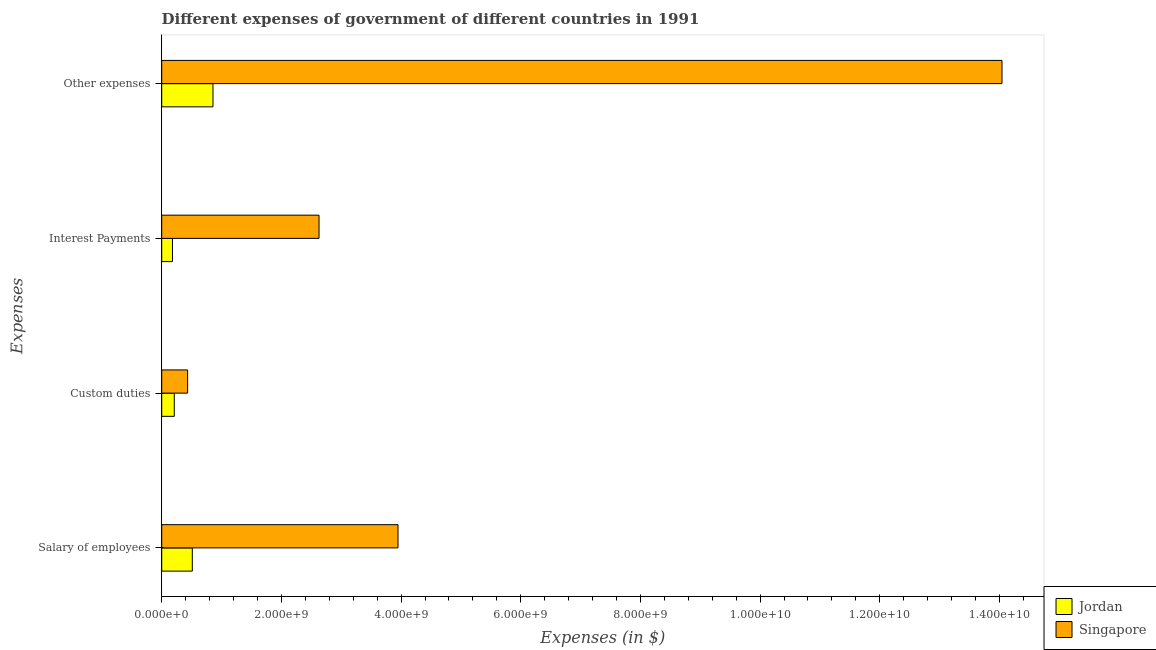How many different coloured bars are there?
Give a very brief answer. 2. Are the number of bars per tick equal to the number of legend labels?
Give a very brief answer. Yes. What is the label of the 4th group of bars from the top?
Make the answer very short. Salary of employees. What is the amount spent on interest payments in Jordan?
Provide a short and direct response. 1.80e+08. Across all countries, what is the maximum amount spent on custom duties?
Your answer should be very brief. 4.33e+08. Across all countries, what is the minimum amount spent on interest payments?
Provide a succinct answer. 1.80e+08. In which country was the amount spent on other expenses maximum?
Your response must be concise. Singapore. In which country was the amount spent on interest payments minimum?
Provide a succinct answer. Jordan. What is the total amount spent on custom duties in the graph?
Ensure brevity in your answer.  6.43e+08. What is the difference between the amount spent on other expenses in Singapore and that in Jordan?
Give a very brief answer. 1.32e+1. What is the difference between the amount spent on interest payments in Jordan and the amount spent on other expenses in Singapore?
Give a very brief answer. -1.39e+1. What is the average amount spent on salary of employees per country?
Make the answer very short. 2.23e+09. What is the difference between the amount spent on salary of employees and amount spent on custom duties in Singapore?
Offer a very short reply. 3.52e+09. In how many countries, is the amount spent on interest payments greater than 8800000000 $?
Offer a very short reply. 0. What is the ratio of the amount spent on other expenses in Singapore to that in Jordan?
Offer a terse response. 16.39. Is the difference between the amount spent on interest payments in Singapore and Jordan greater than the difference between the amount spent on salary of employees in Singapore and Jordan?
Give a very brief answer. No. What is the difference between the highest and the second highest amount spent on interest payments?
Offer a very short reply. 2.45e+09. What is the difference between the highest and the lowest amount spent on interest payments?
Provide a succinct answer. 2.45e+09. In how many countries, is the amount spent on interest payments greater than the average amount spent on interest payments taken over all countries?
Ensure brevity in your answer.  1. Is the sum of the amount spent on custom duties in Singapore and Jordan greater than the maximum amount spent on other expenses across all countries?
Provide a short and direct response. No. What does the 2nd bar from the top in Other expenses represents?
Make the answer very short. Jordan. What does the 1st bar from the bottom in Interest Payments represents?
Give a very brief answer. Jordan. Is it the case that in every country, the sum of the amount spent on salary of employees and amount spent on custom duties is greater than the amount spent on interest payments?
Provide a short and direct response. Yes. How many bars are there?
Offer a very short reply. 8. How many countries are there in the graph?
Offer a very short reply. 2. What is the difference between two consecutive major ticks on the X-axis?
Offer a terse response. 2.00e+09. Are the values on the major ticks of X-axis written in scientific E-notation?
Offer a very short reply. Yes. Does the graph contain any zero values?
Offer a very short reply. No. Does the graph contain grids?
Offer a terse response. No. How many legend labels are there?
Keep it short and to the point. 2. How are the legend labels stacked?
Provide a succinct answer. Vertical. What is the title of the graph?
Your response must be concise. Different expenses of government of different countries in 1991. Does "Netherlands" appear as one of the legend labels in the graph?
Keep it short and to the point. No. What is the label or title of the X-axis?
Provide a short and direct response. Expenses (in $). What is the label or title of the Y-axis?
Your answer should be compact. Expenses. What is the Expenses (in $) of Jordan in Salary of employees?
Your answer should be very brief. 5.11e+08. What is the Expenses (in $) of Singapore in Salary of employees?
Provide a succinct answer. 3.95e+09. What is the Expenses (in $) in Jordan in Custom duties?
Your response must be concise. 2.10e+08. What is the Expenses (in $) of Singapore in Custom duties?
Make the answer very short. 4.33e+08. What is the Expenses (in $) of Jordan in Interest Payments?
Provide a short and direct response. 1.80e+08. What is the Expenses (in $) in Singapore in Interest Payments?
Offer a terse response. 2.63e+09. What is the Expenses (in $) of Jordan in Other expenses?
Offer a very short reply. 8.57e+08. What is the Expenses (in $) of Singapore in Other expenses?
Provide a short and direct response. 1.40e+1. Across all Expenses, what is the maximum Expenses (in $) of Jordan?
Ensure brevity in your answer.  8.57e+08. Across all Expenses, what is the maximum Expenses (in $) in Singapore?
Give a very brief answer. 1.40e+1. Across all Expenses, what is the minimum Expenses (in $) in Jordan?
Give a very brief answer. 1.80e+08. Across all Expenses, what is the minimum Expenses (in $) in Singapore?
Give a very brief answer. 4.33e+08. What is the total Expenses (in $) in Jordan in the graph?
Keep it short and to the point. 1.76e+09. What is the total Expenses (in $) in Singapore in the graph?
Ensure brevity in your answer.  2.11e+1. What is the difference between the Expenses (in $) in Jordan in Salary of employees and that in Custom duties?
Offer a very short reply. 3.01e+08. What is the difference between the Expenses (in $) in Singapore in Salary of employees and that in Custom duties?
Make the answer very short. 3.52e+09. What is the difference between the Expenses (in $) of Jordan in Salary of employees and that in Interest Payments?
Provide a succinct answer. 3.31e+08. What is the difference between the Expenses (in $) of Singapore in Salary of employees and that in Interest Payments?
Give a very brief answer. 1.32e+09. What is the difference between the Expenses (in $) of Jordan in Salary of employees and that in Other expenses?
Provide a succinct answer. -3.45e+08. What is the difference between the Expenses (in $) in Singapore in Salary of employees and that in Other expenses?
Provide a succinct answer. -1.01e+1. What is the difference between the Expenses (in $) of Jordan in Custom duties and that in Interest Payments?
Offer a terse response. 3.00e+07. What is the difference between the Expenses (in $) of Singapore in Custom duties and that in Interest Payments?
Your response must be concise. -2.20e+09. What is the difference between the Expenses (in $) in Jordan in Custom duties and that in Other expenses?
Keep it short and to the point. -6.46e+08. What is the difference between the Expenses (in $) of Singapore in Custom duties and that in Other expenses?
Ensure brevity in your answer.  -1.36e+1. What is the difference between the Expenses (in $) of Jordan in Interest Payments and that in Other expenses?
Offer a terse response. -6.76e+08. What is the difference between the Expenses (in $) in Singapore in Interest Payments and that in Other expenses?
Your answer should be compact. -1.14e+1. What is the difference between the Expenses (in $) in Jordan in Salary of employees and the Expenses (in $) in Singapore in Custom duties?
Your answer should be very brief. 7.84e+07. What is the difference between the Expenses (in $) in Jordan in Salary of employees and the Expenses (in $) in Singapore in Interest Payments?
Your answer should be compact. -2.12e+09. What is the difference between the Expenses (in $) in Jordan in Salary of employees and the Expenses (in $) in Singapore in Other expenses?
Offer a terse response. -1.35e+1. What is the difference between the Expenses (in $) in Jordan in Custom duties and the Expenses (in $) in Singapore in Interest Payments?
Ensure brevity in your answer.  -2.42e+09. What is the difference between the Expenses (in $) in Jordan in Custom duties and the Expenses (in $) in Singapore in Other expenses?
Offer a very short reply. -1.38e+1. What is the difference between the Expenses (in $) of Jordan in Interest Payments and the Expenses (in $) of Singapore in Other expenses?
Make the answer very short. -1.39e+1. What is the average Expenses (in $) in Jordan per Expenses?
Provide a succinct answer. 4.40e+08. What is the average Expenses (in $) in Singapore per Expenses?
Give a very brief answer. 5.26e+09. What is the difference between the Expenses (in $) in Jordan and Expenses (in $) in Singapore in Salary of employees?
Your response must be concise. -3.44e+09. What is the difference between the Expenses (in $) of Jordan and Expenses (in $) of Singapore in Custom duties?
Your answer should be compact. -2.23e+08. What is the difference between the Expenses (in $) in Jordan and Expenses (in $) in Singapore in Interest Payments?
Give a very brief answer. -2.45e+09. What is the difference between the Expenses (in $) of Jordan and Expenses (in $) of Singapore in Other expenses?
Give a very brief answer. -1.32e+1. What is the ratio of the Expenses (in $) in Jordan in Salary of employees to that in Custom duties?
Make the answer very short. 2.43. What is the ratio of the Expenses (in $) of Singapore in Salary of employees to that in Custom duties?
Your answer should be very brief. 9.12. What is the ratio of the Expenses (in $) in Jordan in Salary of employees to that in Interest Payments?
Make the answer very short. 2.84. What is the ratio of the Expenses (in $) of Singapore in Salary of employees to that in Interest Payments?
Offer a very short reply. 1.5. What is the ratio of the Expenses (in $) in Jordan in Salary of employees to that in Other expenses?
Offer a very short reply. 0.6. What is the ratio of the Expenses (in $) in Singapore in Salary of employees to that in Other expenses?
Offer a terse response. 0.28. What is the ratio of the Expenses (in $) of Jordan in Custom duties to that in Interest Payments?
Give a very brief answer. 1.17. What is the ratio of the Expenses (in $) in Singapore in Custom duties to that in Interest Payments?
Provide a short and direct response. 0.16. What is the ratio of the Expenses (in $) of Jordan in Custom duties to that in Other expenses?
Provide a short and direct response. 0.25. What is the ratio of the Expenses (in $) in Singapore in Custom duties to that in Other expenses?
Ensure brevity in your answer.  0.03. What is the ratio of the Expenses (in $) in Jordan in Interest Payments to that in Other expenses?
Offer a very short reply. 0.21. What is the ratio of the Expenses (in $) of Singapore in Interest Payments to that in Other expenses?
Give a very brief answer. 0.19. What is the difference between the highest and the second highest Expenses (in $) of Jordan?
Your answer should be compact. 3.45e+08. What is the difference between the highest and the second highest Expenses (in $) in Singapore?
Your answer should be very brief. 1.01e+1. What is the difference between the highest and the lowest Expenses (in $) of Jordan?
Provide a short and direct response. 6.76e+08. What is the difference between the highest and the lowest Expenses (in $) of Singapore?
Your response must be concise. 1.36e+1. 